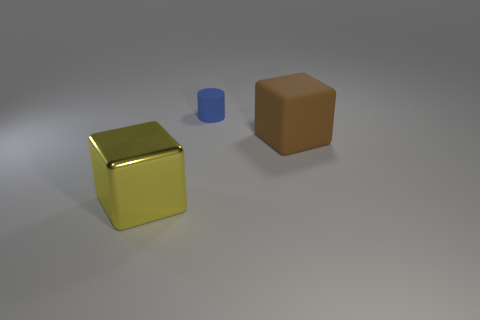What number of blue things are either matte blocks or tiny objects?
Offer a terse response. 1. What number of other objects are there of the same size as the cylinder?
Provide a succinct answer. 0. How many large things are either yellow things or gray rubber balls?
Your response must be concise. 1. Do the shiny thing and the cube that is to the right of the large yellow thing have the same size?
Give a very brief answer. Yes. How many other objects are the same shape as the metal object?
Make the answer very short. 1. What shape is the small thing that is the same material as the big brown block?
Your response must be concise. Cylinder. Are there any small blue rubber cylinders?
Keep it short and to the point. Yes. Are there fewer brown matte blocks that are left of the small thing than blocks on the right side of the large brown block?
Provide a succinct answer. No. What shape is the big yellow thing left of the small blue rubber cylinder?
Give a very brief answer. Cube. Do the blue thing and the big brown thing have the same material?
Keep it short and to the point. Yes. 